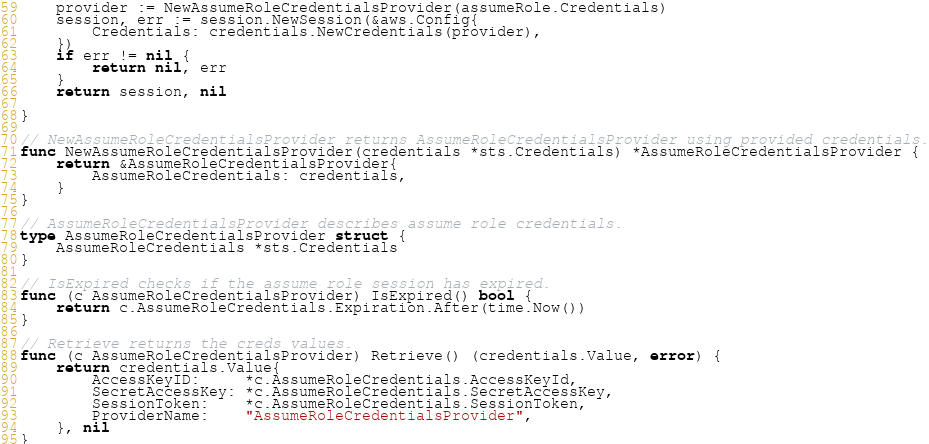<code> <loc_0><loc_0><loc_500><loc_500><_Go_>	provider := NewAssumeRoleCredentialsProvider(assumeRole.Credentials)
	session, err := session.NewSession(&aws.Config{
		Credentials: credentials.NewCredentials(provider),
	})
	if err != nil {
		return nil, err
	}
	return session, nil

}

// NewAssumeRoleCredentialsProvider returns AssumeRoleCredentialsProvider using provided credentials.
func NewAssumeRoleCredentialsProvider(credentials *sts.Credentials) *AssumeRoleCredentialsProvider {
	return &AssumeRoleCredentialsProvider{
		AssumeRoleCredentials: credentials,
	}
}

// AssumeRoleCredentialsProvider describes assume role credentials.
type AssumeRoleCredentialsProvider struct {
	AssumeRoleCredentials *sts.Credentials
}

// IsExpired checks if the assume role session has expired.
func (c AssumeRoleCredentialsProvider) IsExpired() bool {
	return c.AssumeRoleCredentials.Expiration.After(time.Now())
}

// Retrieve returns the creds values.
func (c AssumeRoleCredentialsProvider) Retrieve() (credentials.Value, error) {
	return credentials.Value{
		AccessKeyID:     *c.AssumeRoleCredentials.AccessKeyId,
		SecretAccessKey: *c.AssumeRoleCredentials.SecretAccessKey,
		SessionToken:    *c.AssumeRoleCredentials.SessionToken,
		ProviderName:    "AssumeRoleCredentialsProvider",
	}, nil
}
</code> 